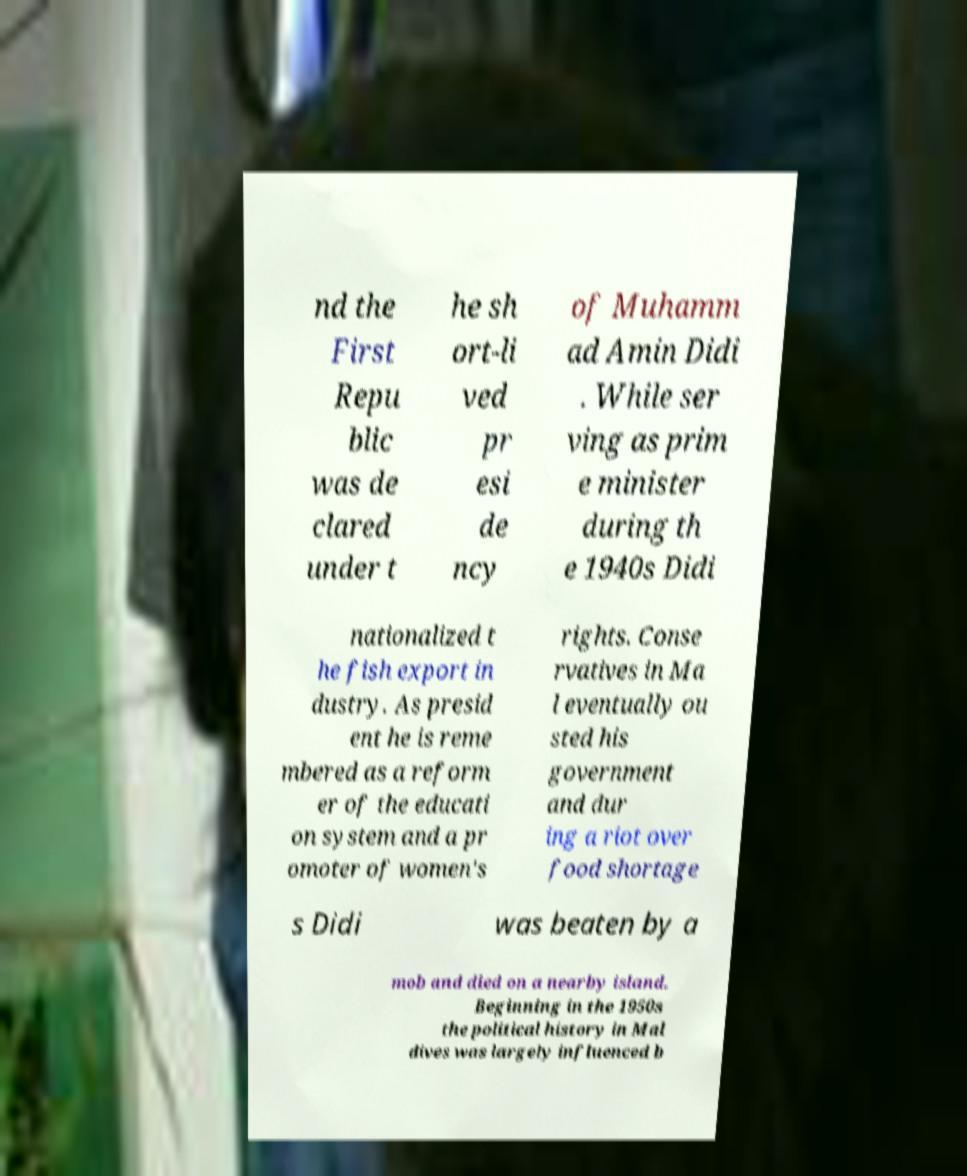Could you assist in decoding the text presented in this image and type it out clearly? nd the First Repu blic was de clared under t he sh ort-li ved pr esi de ncy of Muhamm ad Amin Didi . While ser ving as prim e minister during th e 1940s Didi nationalized t he fish export in dustry. As presid ent he is reme mbered as a reform er of the educati on system and a pr omoter of women's rights. Conse rvatives in Ma l eventually ou sted his government and dur ing a riot over food shortage s Didi was beaten by a mob and died on a nearby island. Beginning in the 1950s the political history in Mal dives was largely influenced b 